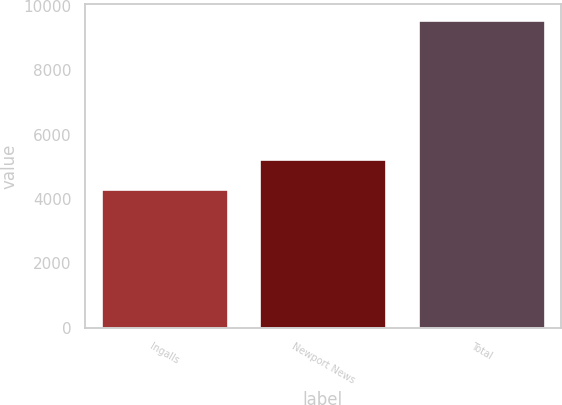<chart> <loc_0><loc_0><loc_500><loc_500><bar_chart><fcel>Ingalls<fcel>Newport News<fcel>Total<nl><fcel>4317<fcel>5248<fcel>9565<nl></chart> 